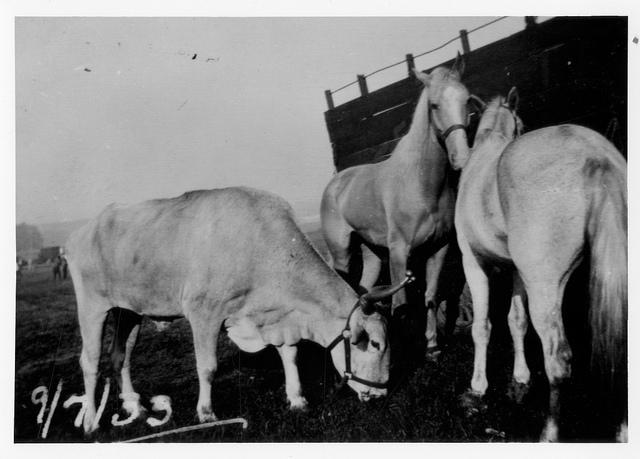Where are the horses at?
Concise answer only. Farm. Is this the desert?
Write a very short answer. No. What date was this photo taken?
Short answer required. 9/7/33. Is this entertaining?
Give a very brief answer. No. 